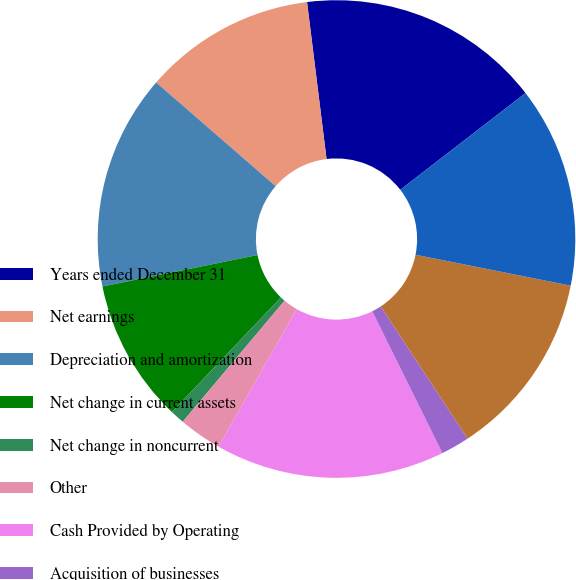<chart> <loc_0><loc_0><loc_500><loc_500><pie_chart><fcel>Years ended December 31<fcel>Net earnings<fcel>Depreciation and amortization<fcel>Net change in current assets<fcel>Net change in noncurrent<fcel>Other<fcel>Cash Provided by Operating<fcel>Acquisition of businesses<fcel>Capital expenditures<fcel>Cash Used in Investing<nl><fcel>16.5%<fcel>11.65%<fcel>14.56%<fcel>9.71%<fcel>0.97%<fcel>2.91%<fcel>15.53%<fcel>1.94%<fcel>12.62%<fcel>13.59%<nl></chart> 